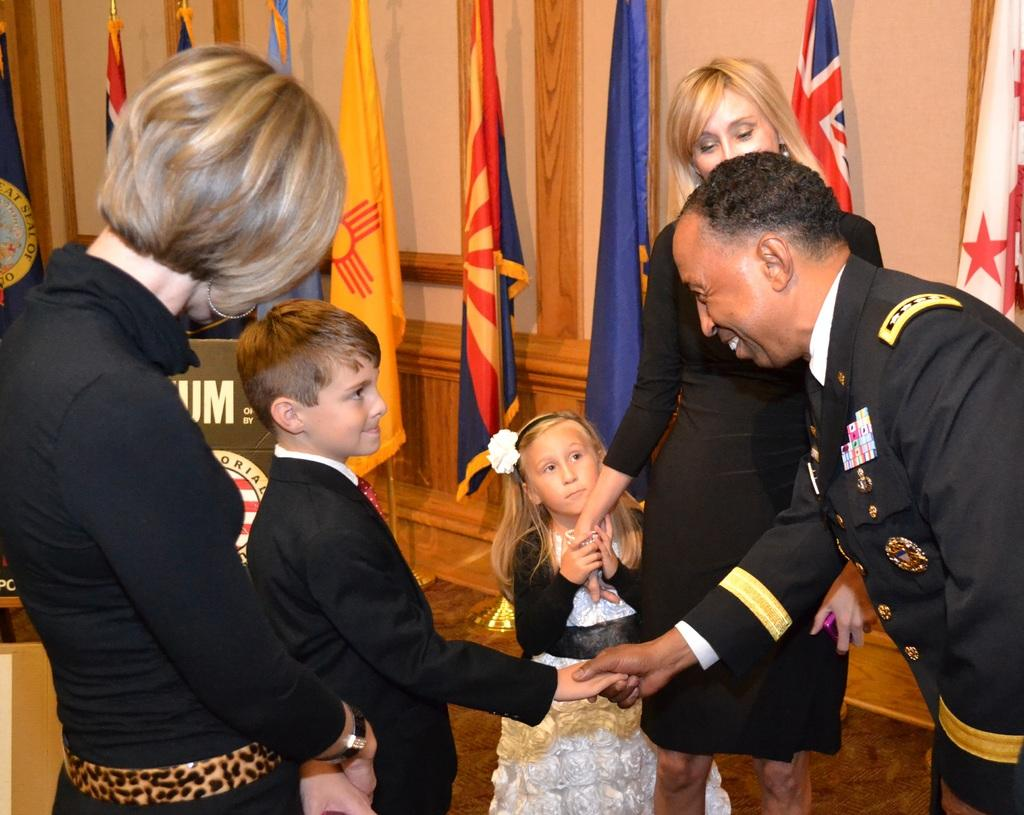How many people are in the image? There is a group of people in the image. What colors are the dresses of some people in the group? Some of the people are wearing white and black color dresses. Can you identify any accessories worn by the people in the group? One person in the group is wearing specs. What can be seen in the background of the image? There are many colorful flags and a wall visible in the background of the image. What type of advertisement can be seen on the wall in the image? There is no advertisement visible on the wall in the image. What is the paste used for in the image? There is no mention of paste or any activity involving paste in the image. 